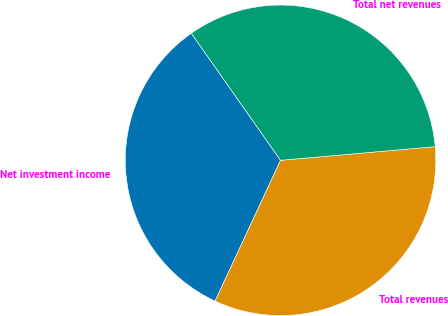Convert chart. <chart><loc_0><loc_0><loc_500><loc_500><pie_chart><fcel>Net investment income<fcel>Total revenues<fcel>Total net revenues<nl><fcel>33.32%<fcel>33.33%<fcel>33.34%<nl></chart> 